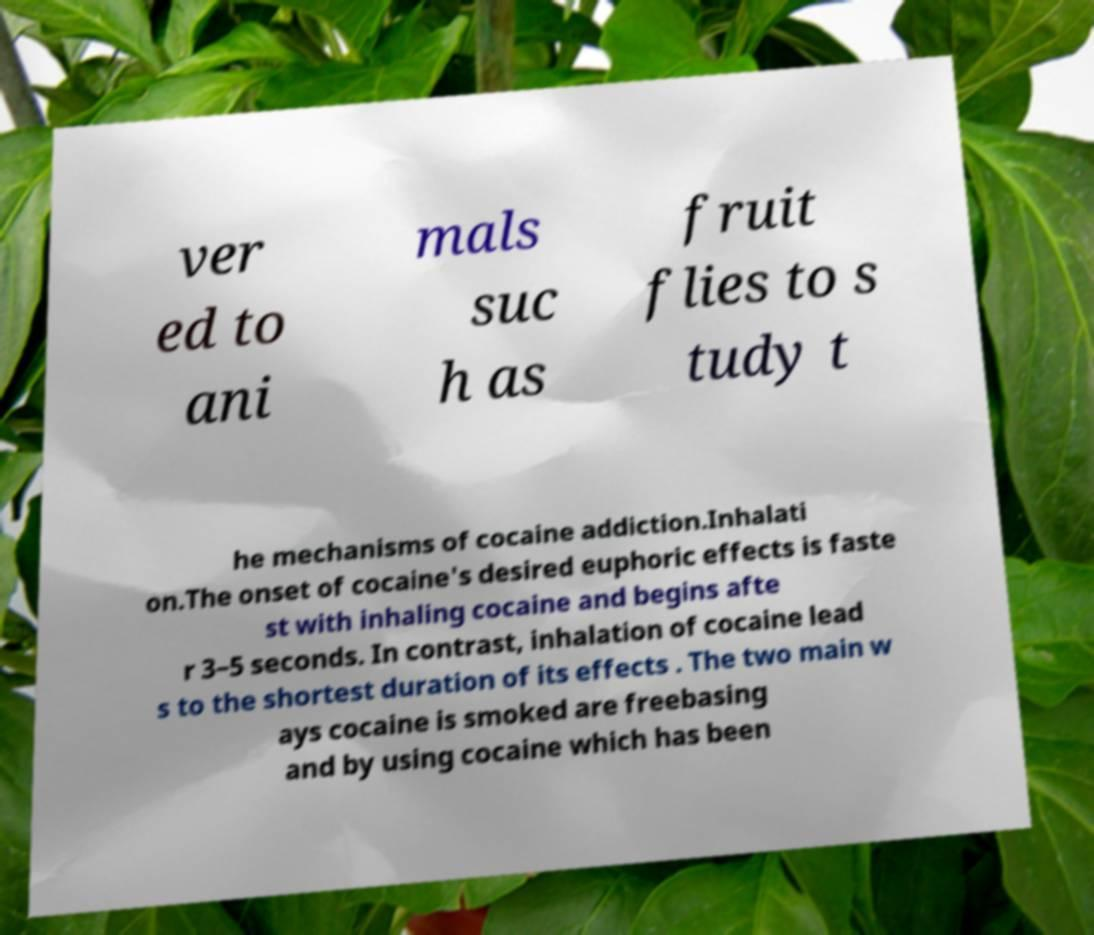For documentation purposes, I need the text within this image transcribed. Could you provide that? ver ed to ani mals suc h as fruit flies to s tudy t he mechanisms of cocaine addiction.Inhalati on.The onset of cocaine's desired euphoric effects is faste st with inhaling cocaine and begins afte r 3–5 seconds. In contrast, inhalation of cocaine lead s to the shortest duration of its effects . The two main w ays cocaine is smoked are freebasing and by using cocaine which has been 